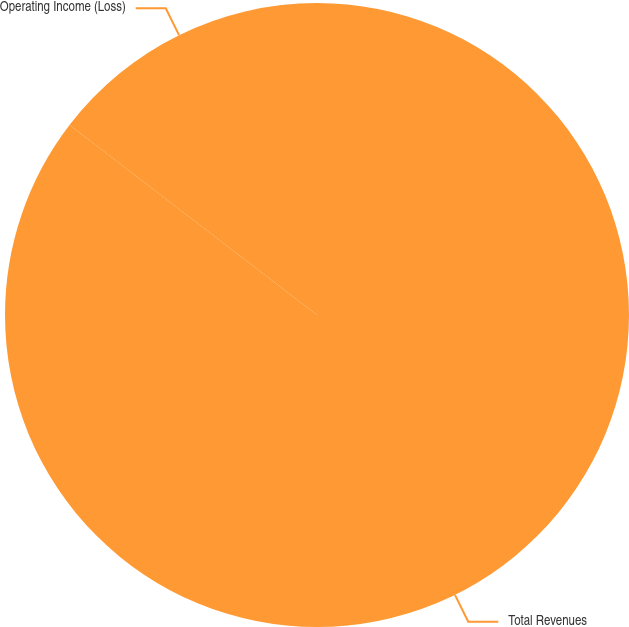Convert chart. <chart><loc_0><loc_0><loc_500><loc_500><pie_chart><fcel>Total Revenues<fcel>Operating Income (Loss)<nl><fcel>85.42%<fcel>14.58%<nl></chart> 